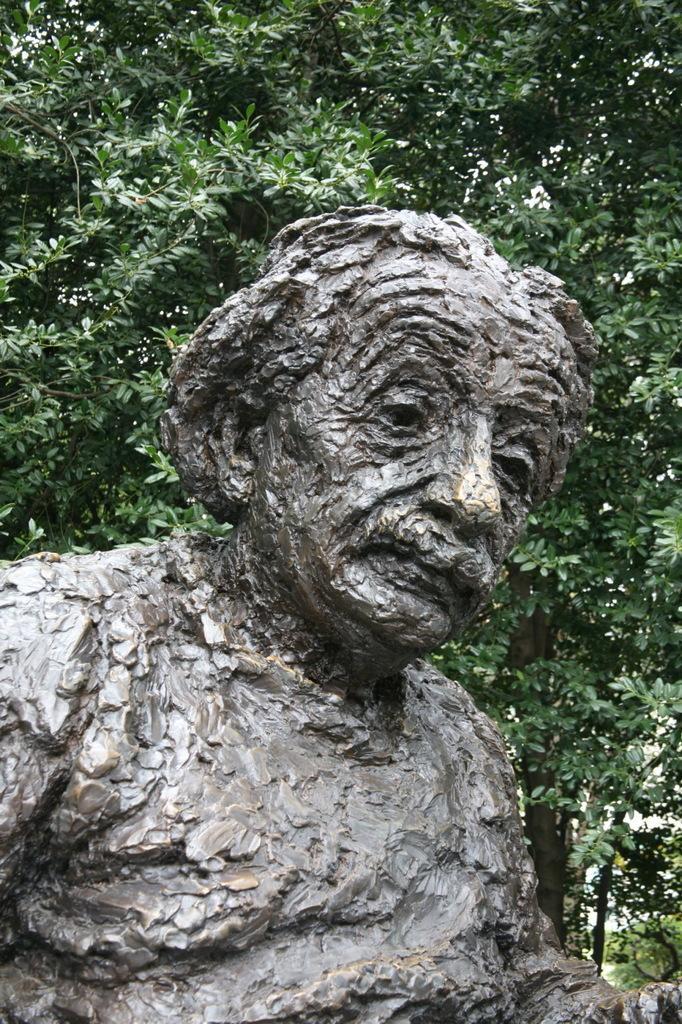Please provide a concise description of this image. In this picture I can see a statue of a man and I can see trees in the back. 